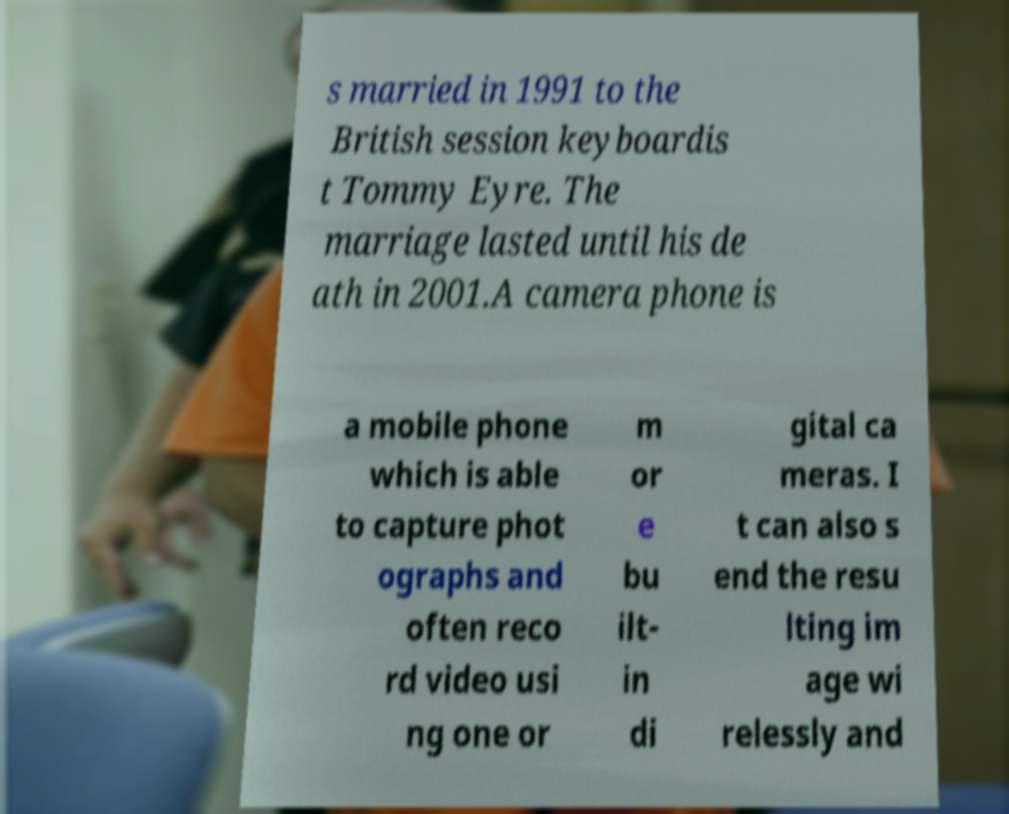Please identify and transcribe the text found in this image. s married in 1991 to the British session keyboardis t Tommy Eyre. The marriage lasted until his de ath in 2001.A camera phone is a mobile phone which is able to capture phot ographs and often reco rd video usi ng one or m or e bu ilt- in di gital ca meras. I t can also s end the resu lting im age wi relessly and 